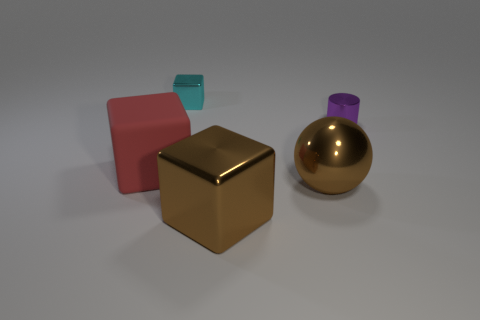Subtract all rubber cubes. How many cubes are left? 2 Add 5 cyan blocks. How many objects exist? 10 Subtract all brown blocks. How many blocks are left? 2 Subtract 1 spheres. How many spheres are left? 0 Subtract all cubes. How many objects are left? 2 Subtract all blue spheres. Subtract all brown cylinders. How many spheres are left? 1 Subtract all cyan blocks. How many blue cylinders are left? 0 Subtract all cyan things. Subtract all matte blocks. How many objects are left? 3 Add 5 brown blocks. How many brown blocks are left? 6 Add 4 purple cylinders. How many purple cylinders exist? 5 